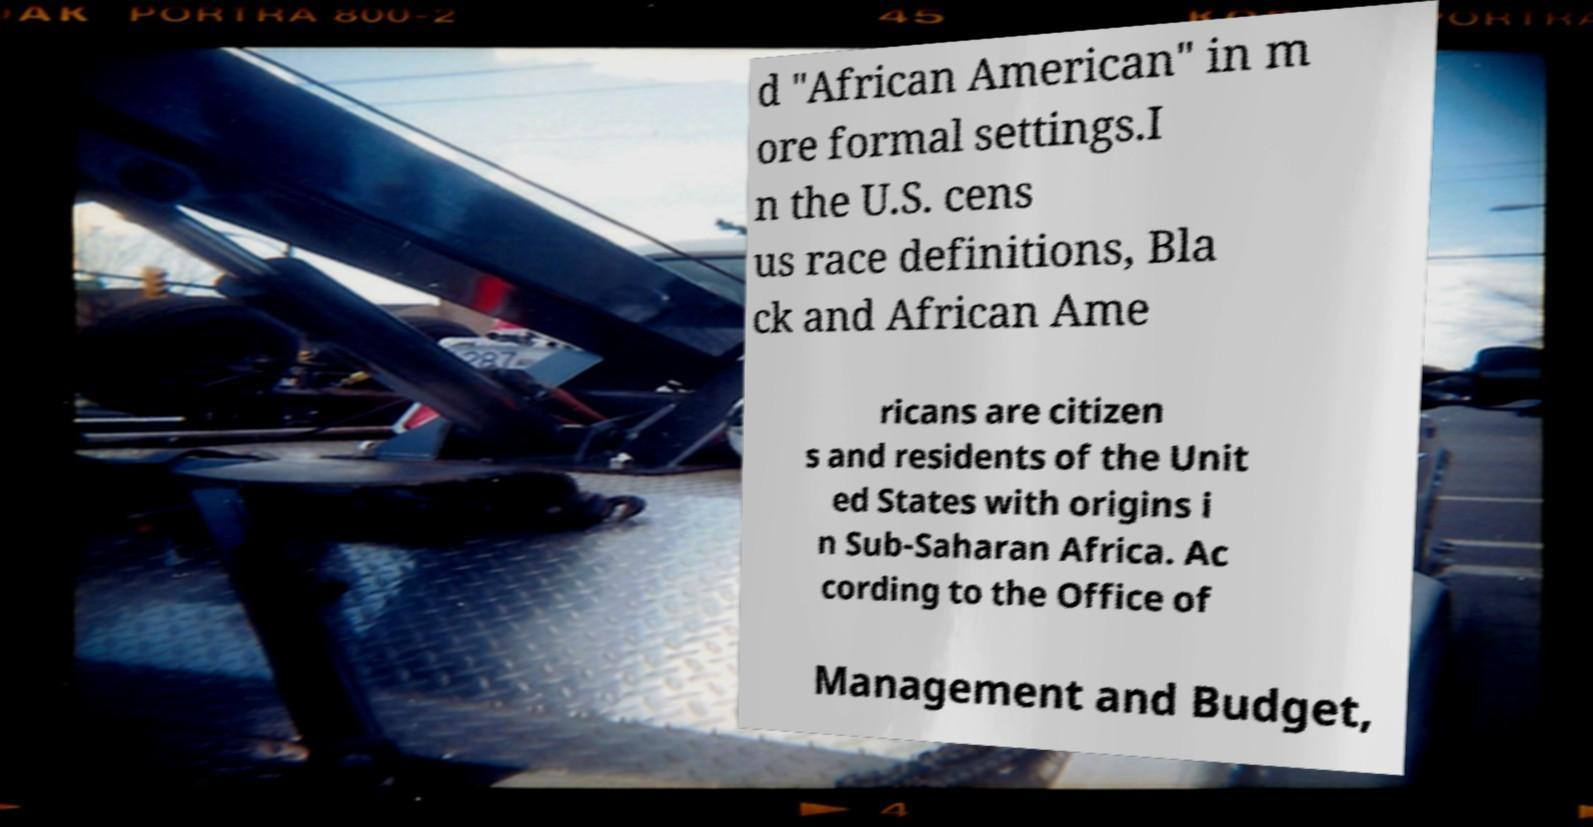There's text embedded in this image that I need extracted. Can you transcribe it verbatim? d "African American" in m ore formal settings.I n the U.S. cens us race definitions, Bla ck and African Ame ricans are citizen s and residents of the Unit ed States with origins i n Sub-Saharan Africa. Ac cording to the Office of Management and Budget, 